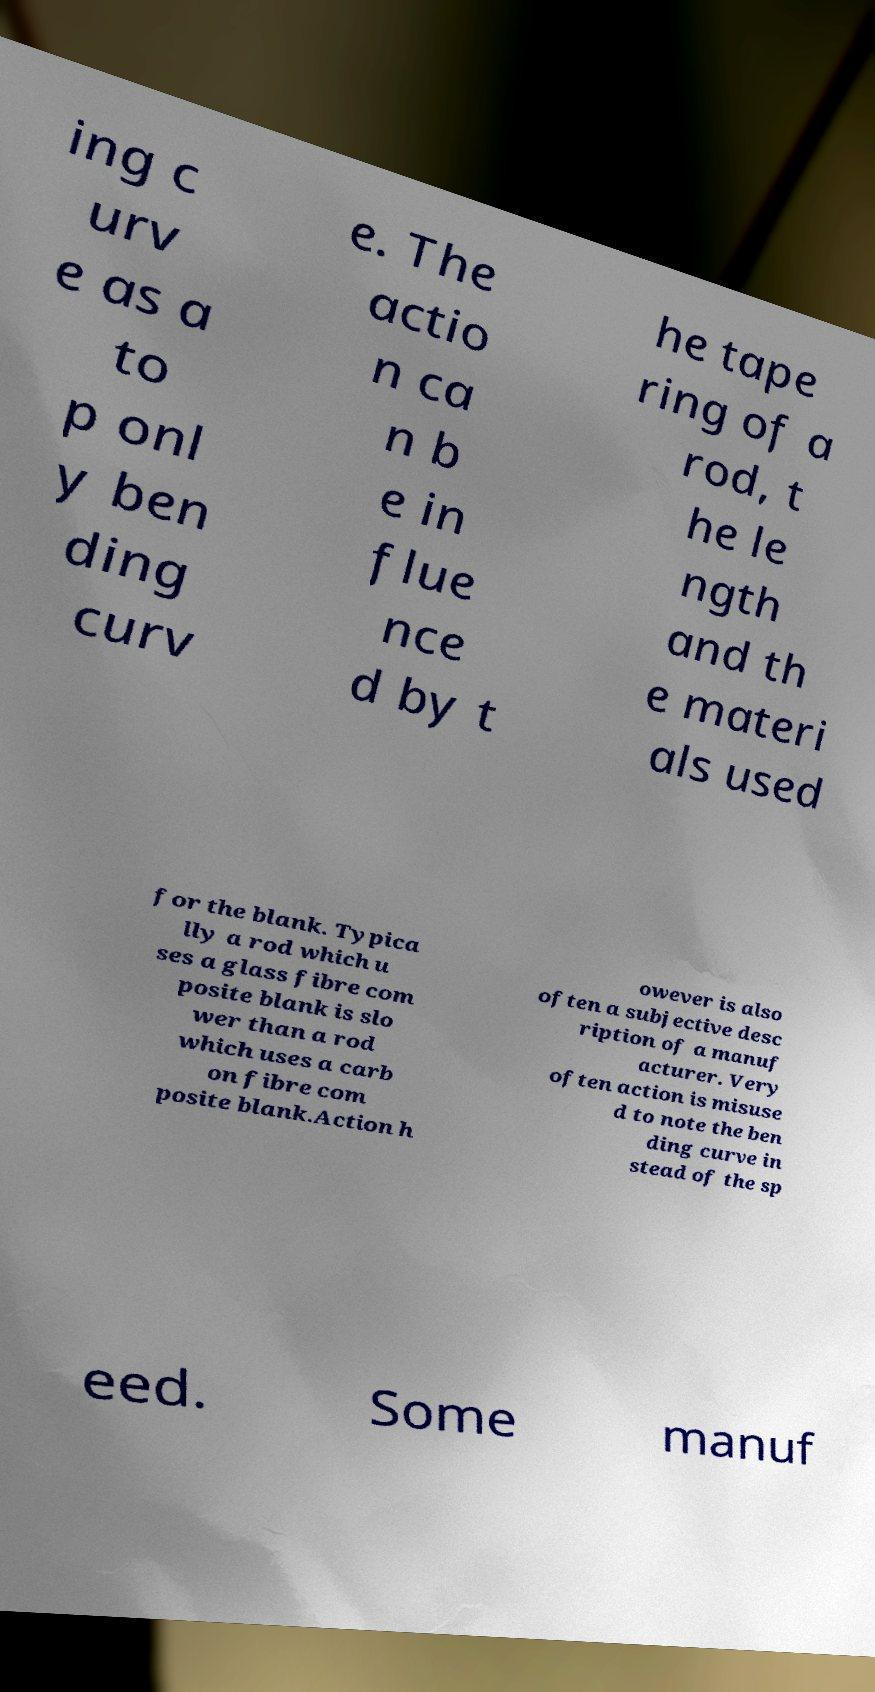What messages or text are displayed in this image? I need them in a readable, typed format. ing c urv e as a to p onl y ben ding curv e. The actio n ca n b e in flue nce d by t he tape ring of a rod, t he le ngth and th e materi als used for the blank. Typica lly a rod which u ses a glass fibre com posite blank is slo wer than a rod which uses a carb on fibre com posite blank.Action h owever is also often a subjective desc ription of a manuf acturer. Very often action is misuse d to note the ben ding curve in stead of the sp eed. Some manuf 